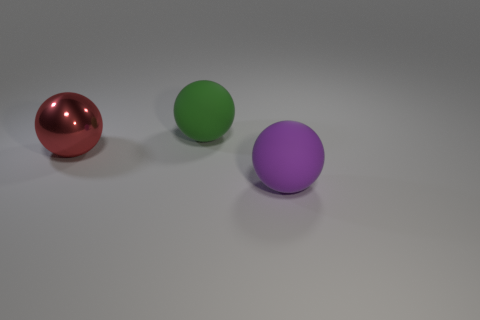Subtract all large shiny balls. How many balls are left? 2 Add 3 big cyan shiny spheres. How many objects exist? 6 Subtract all brown spheres. Subtract all yellow cylinders. How many spheres are left? 3 Subtract all red shiny things. Subtract all red spheres. How many objects are left? 1 Add 2 green objects. How many green objects are left? 3 Add 2 large cyan spheres. How many large cyan spheres exist? 2 Subtract 0 blue balls. How many objects are left? 3 